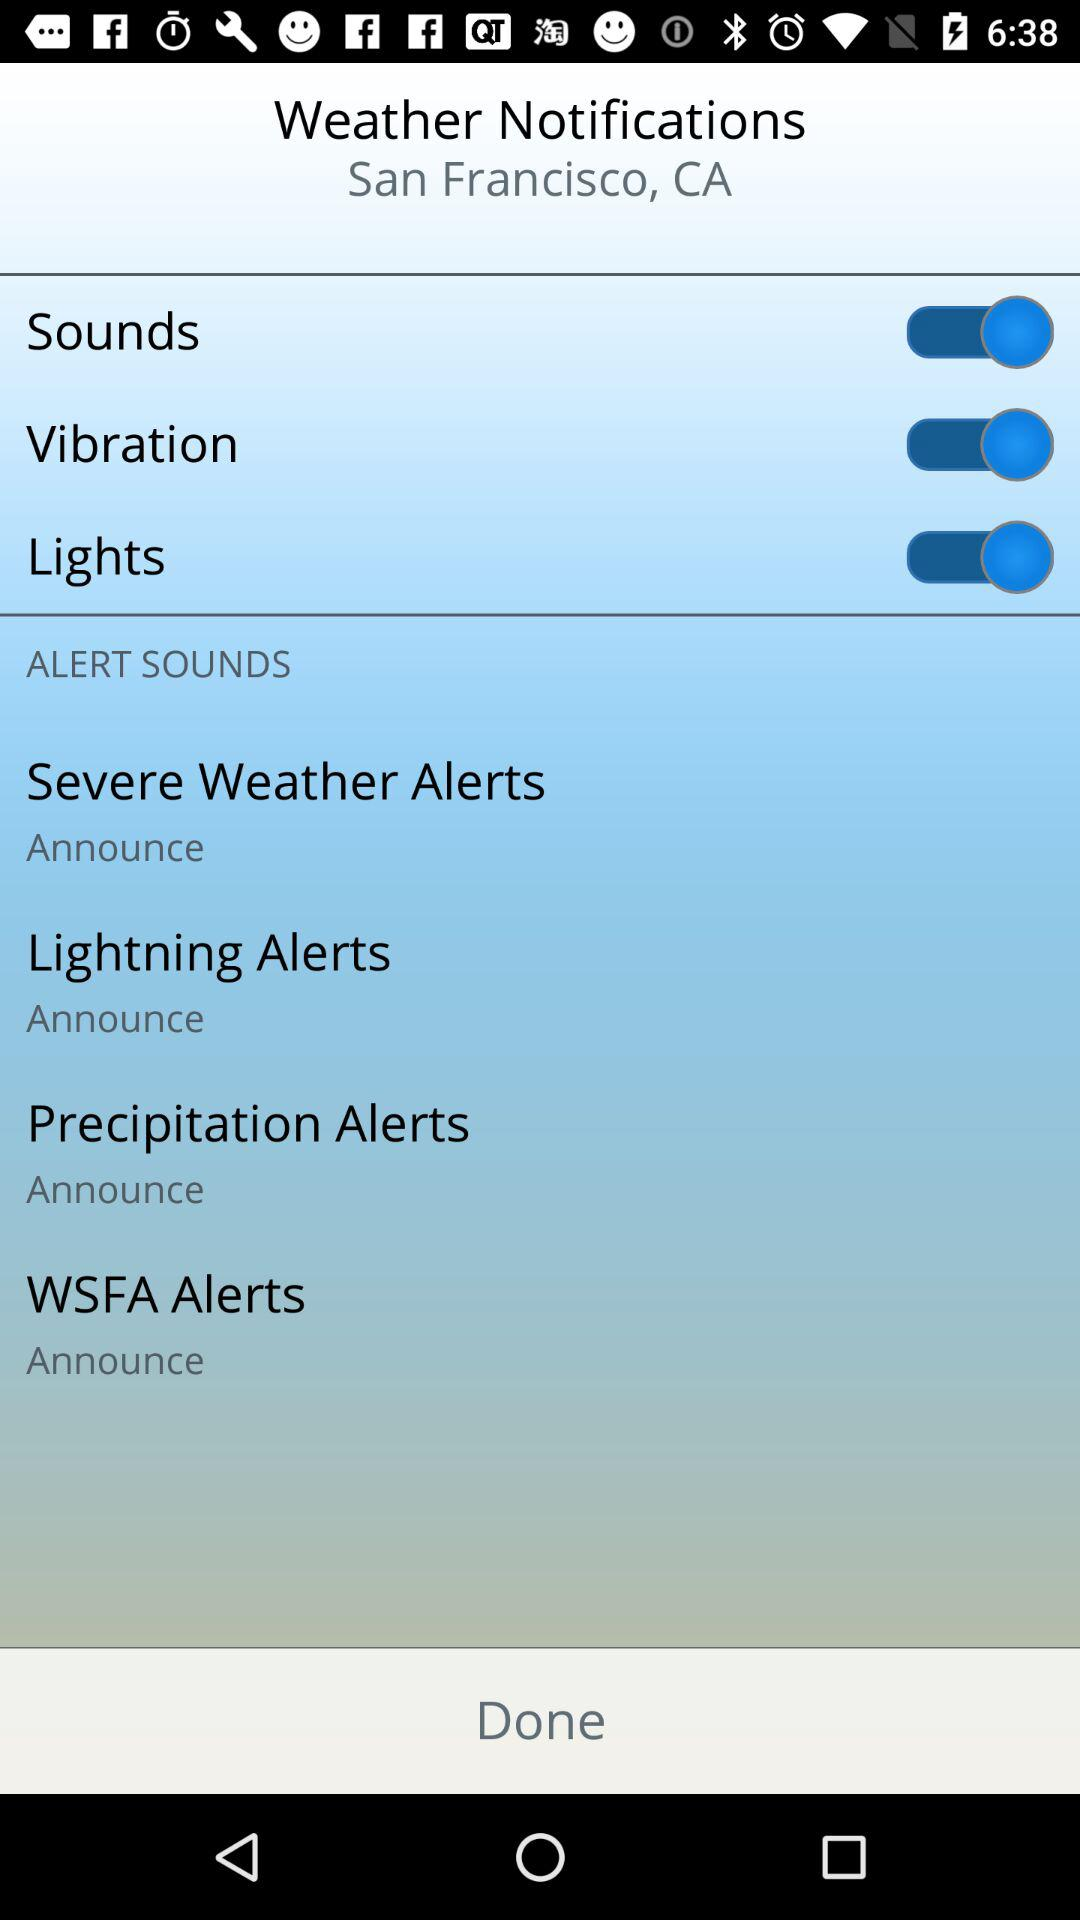What is the status of the "Sounds" setting? The status of the "Sounds" setting is "on". 